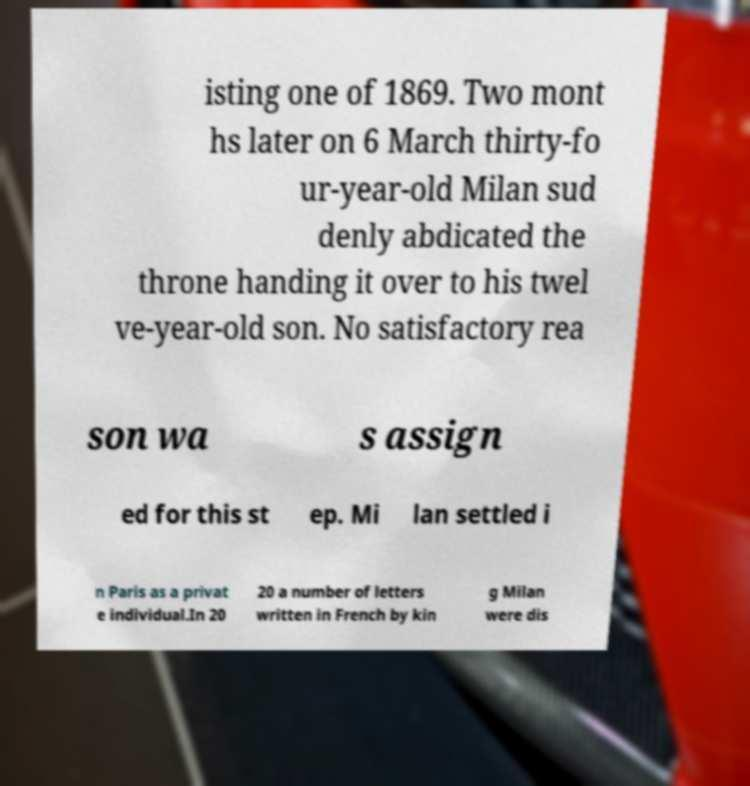Please read and relay the text visible in this image. What does it say? isting one of 1869. Two mont hs later on 6 March thirty-fo ur-year-old Milan sud denly abdicated the throne handing it over to his twel ve-year-old son. No satisfactory rea son wa s assign ed for this st ep. Mi lan settled i n Paris as a privat e individual.In 20 20 a number of letters written in French by kin g Milan were dis 